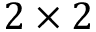<formula> <loc_0><loc_0><loc_500><loc_500>2 \times 2</formula> 